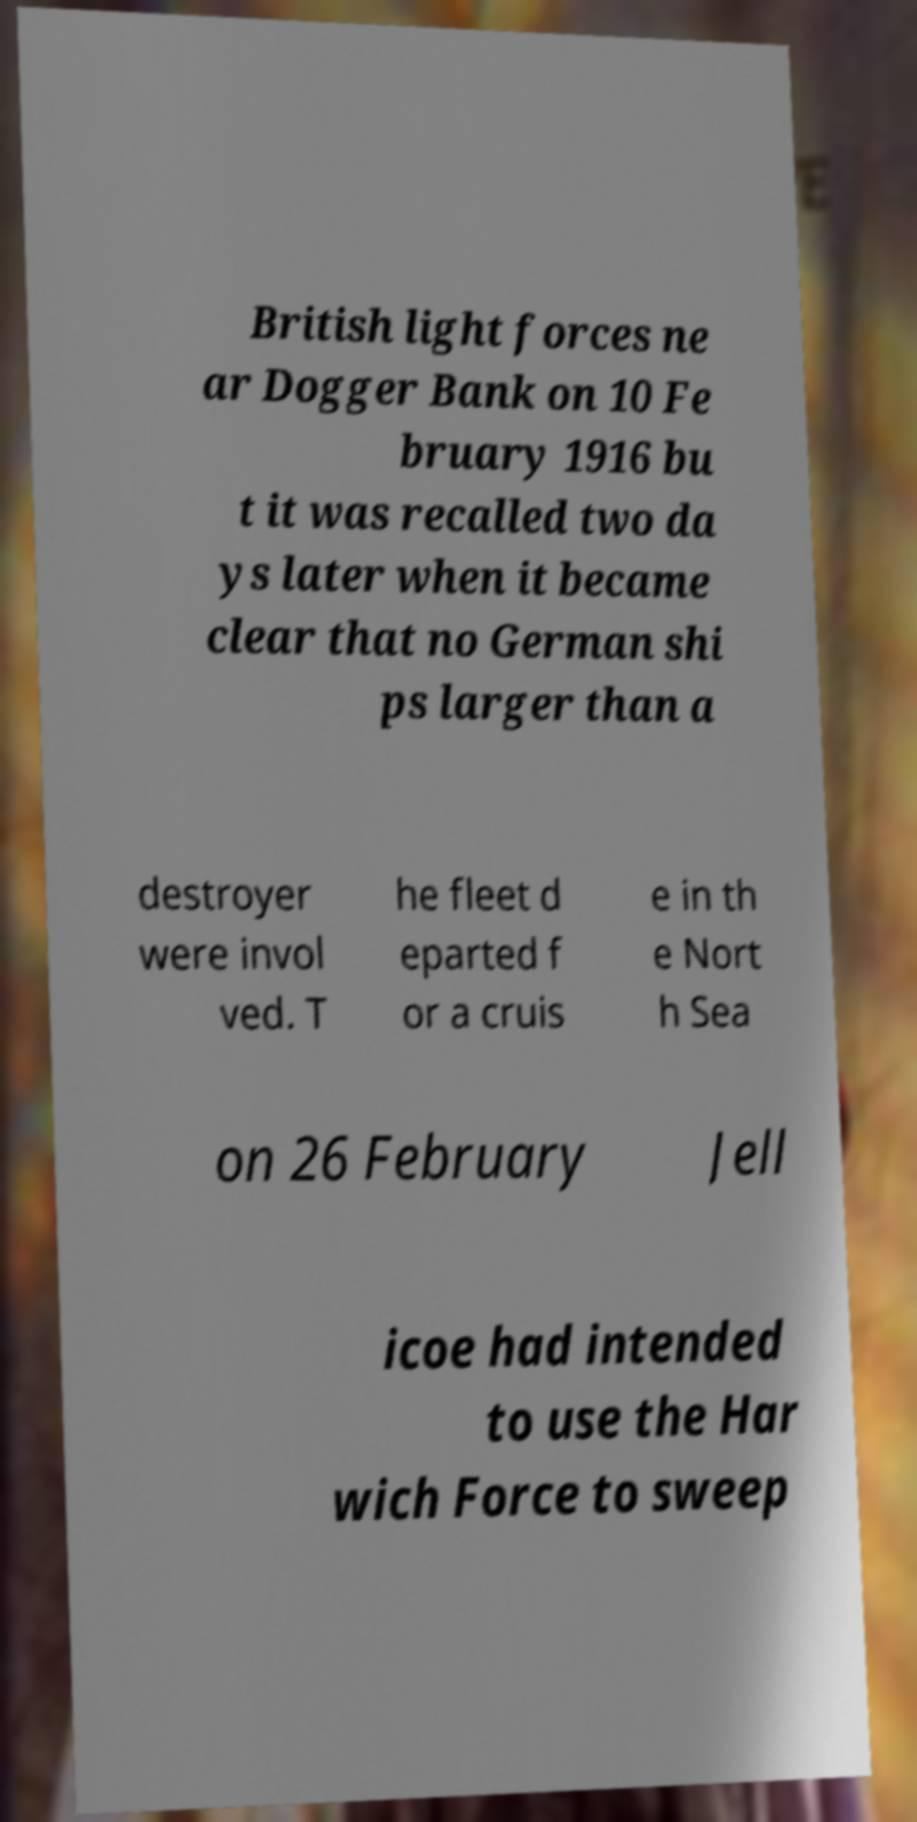Please read and relay the text visible in this image. What does it say? British light forces ne ar Dogger Bank on 10 Fe bruary 1916 bu t it was recalled two da ys later when it became clear that no German shi ps larger than a destroyer were invol ved. T he fleet d eparted f or a cruis e in th e Nort h Sea on 26 February Jell icoe had intended to use the Har wich Force to sweep 